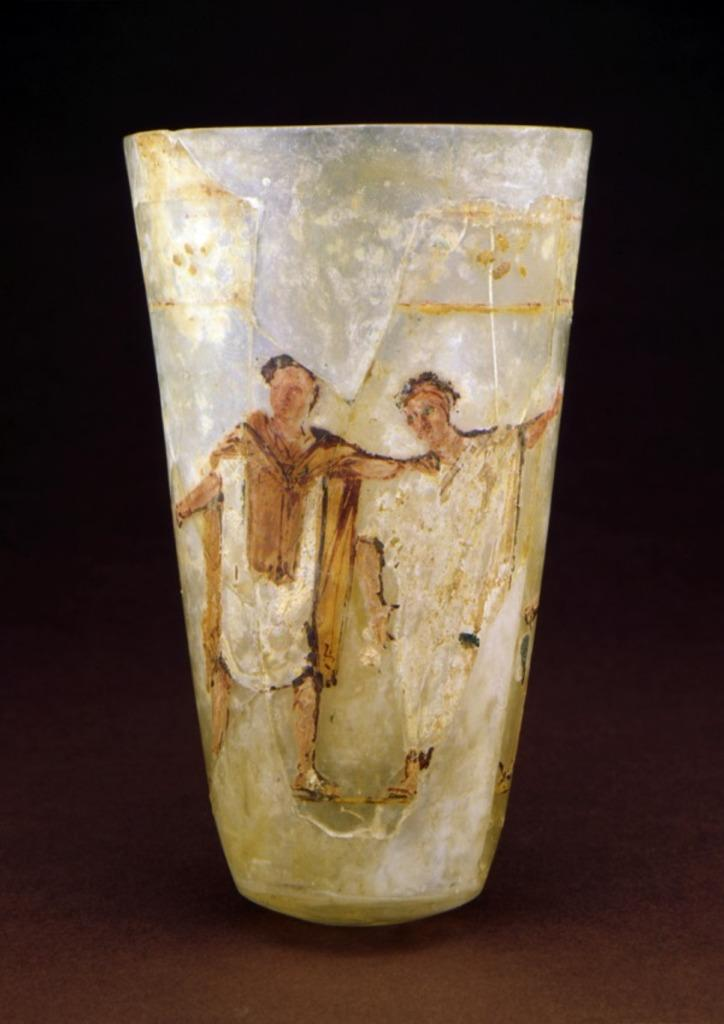What object in the image has a painting on it? The glass in the image has a painting on it. Where is the glass with the painting located? The glass with the painting is on a table. What is the subject matter of the painting? The painting depicts persons standing on the ground. How would you describe the background of the painting? The background of the painting is dark in color. What language is spoken by the persons in the painting? The image does not provide information about the language spoken by the persons in the painting. How many hours does the store in the image remain open? There is no store present in the image. 